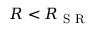<formula> <loc_0><loc_0><loc_500><loc_500>R < R _ { S R }</formula> 